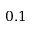<formula> <loc_0><loc_0><loc_500><loc_500>0 . 1</formula> 